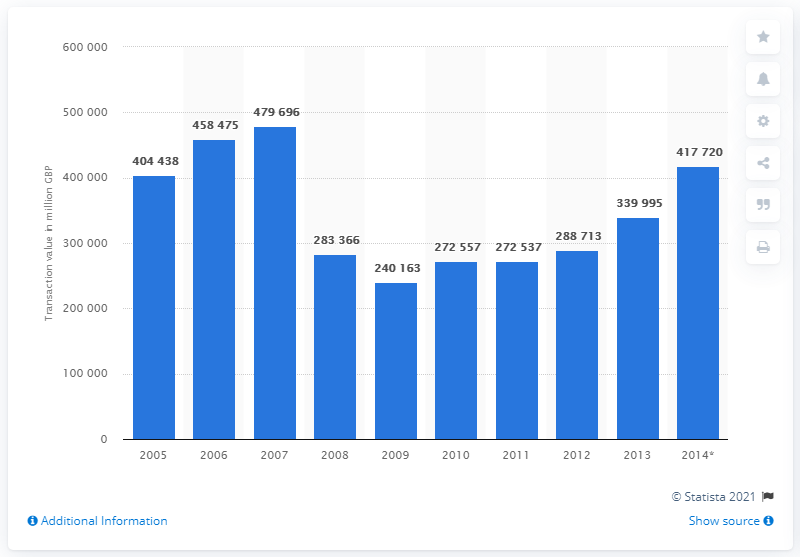Identify some key points in this picture. In 2008, the value of property purchase transactions was 283,366. In 2014, there were 417,720 property purchase transactions with a value. The value of property purchase transactions in 2007 was approximately 479,696. 